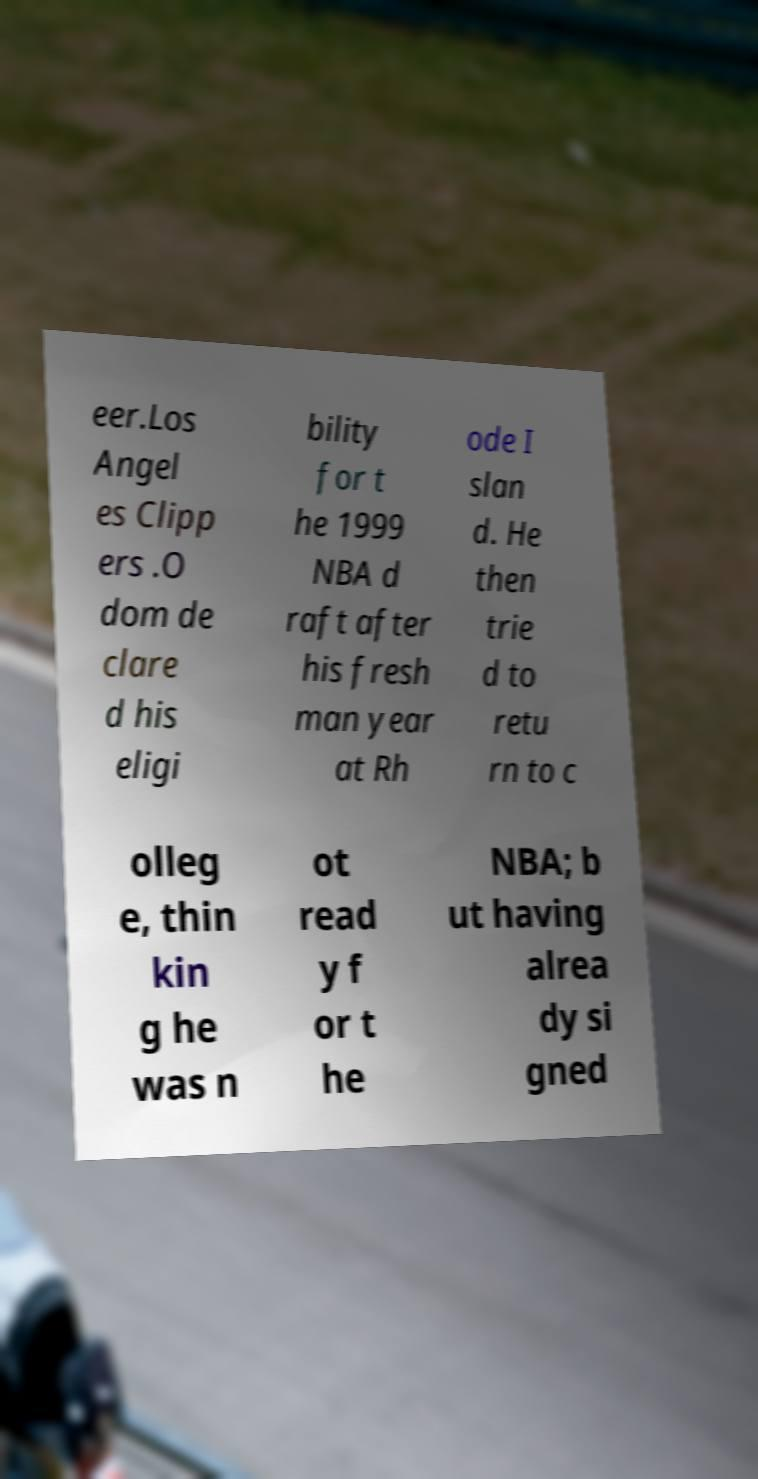Could you assist in decoding the text presented in this image and type it out clearly? eer.Los Angel es Clipp ers .O dom de clare d his eligi bility for t he 1999 NBA d raft after his fresh man year at Rh ode I slan d. He then trie d to retu rn to c olleg e, thin kin g he was n ot read y f or t he NBA; b ut having alrea dy si gned 